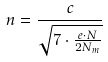Convert formula to latex. <formula><loc_0><loc_0><loc_500><loc_500>n = \frac { c } { \sqrt { 7 \cdot \frac { e \cdot N } { 2 N _ { m } } } }</formula> 